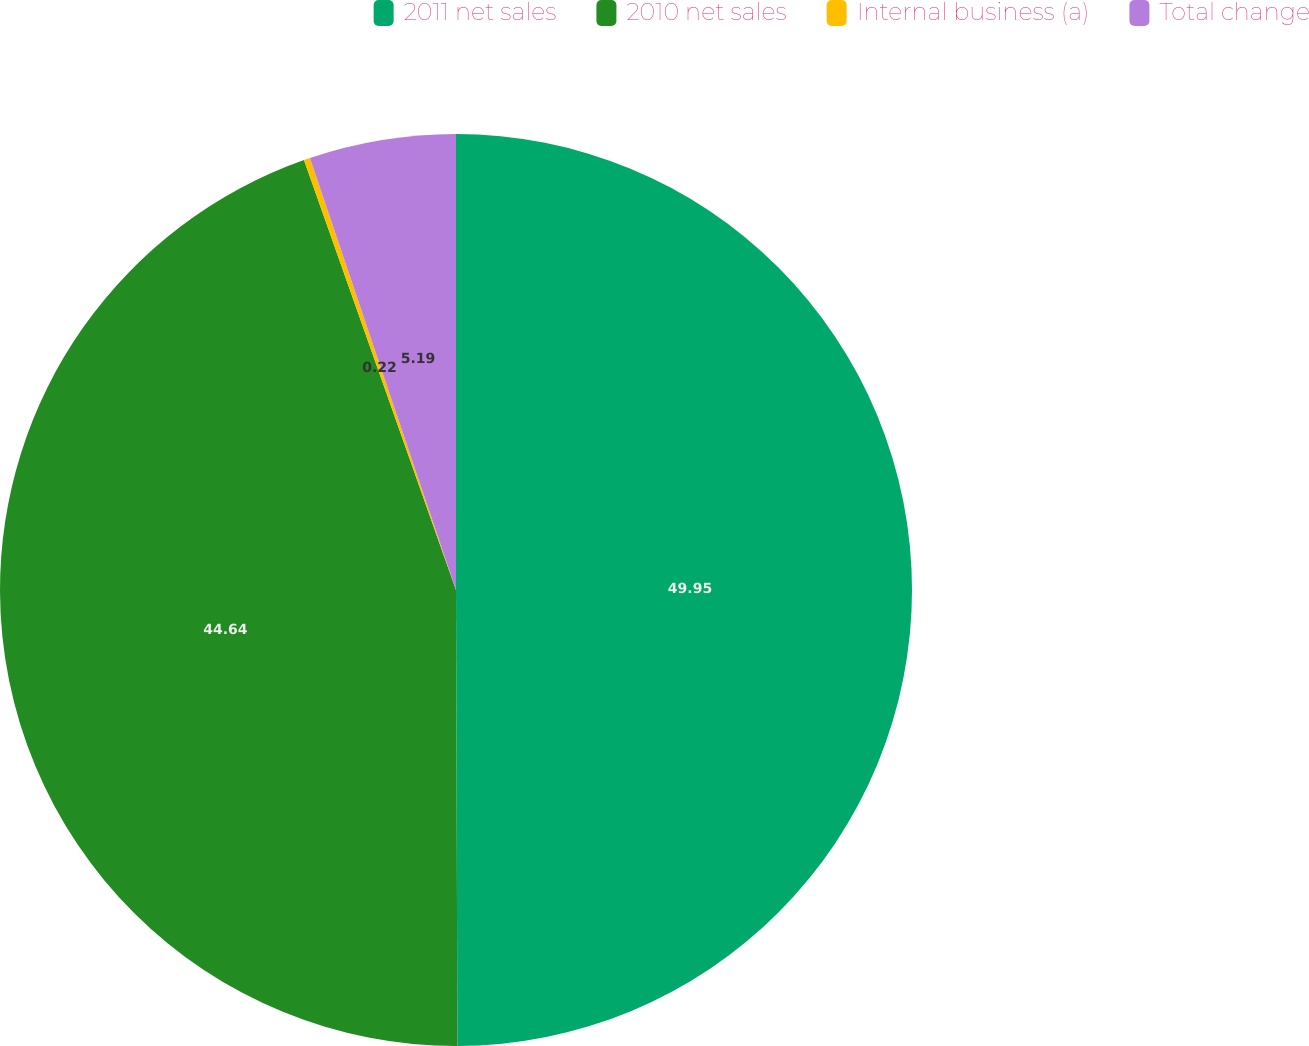<chart> <loc_0><loc_0><loc_500><loc_500><pie_chart><fcel>2011 net sales<fcel>2010 net sales<fcel>Internal business (a)<fcel>Total change<nl><fcel>49.95%<fcel>44.64%<fcel>0.22%<fcel>5.19%<nl></chart> 